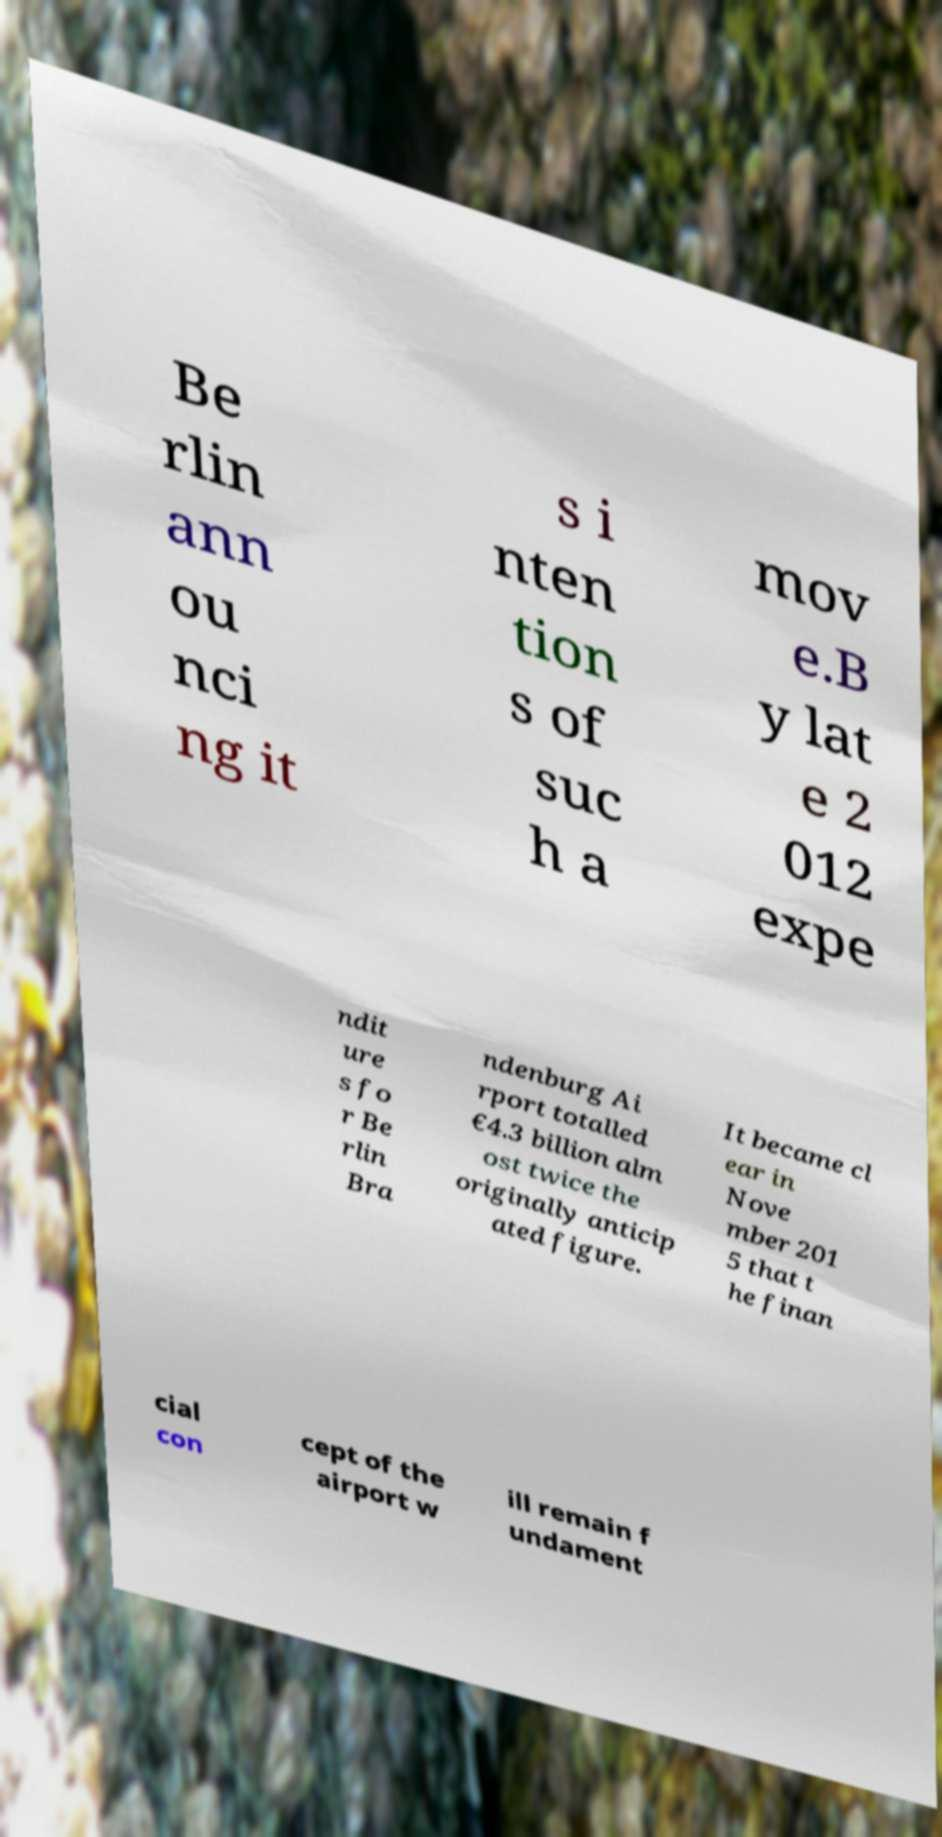There's text embedded in this image that I need extracted. Can you transcribe it verbatim? Be rlin ann ou nci ng it s i nten tion s of suc h a mov e.B y lat e 2 012 expe ndit ure s fo r Be rlin Bra ndenburg Ai rport totalled €4.3 billion alm ost twice the originally anticip ated figure. It became cl ear in Nove mber 201 5 that t he finan cial con cept of the airport w ill remain f undament 